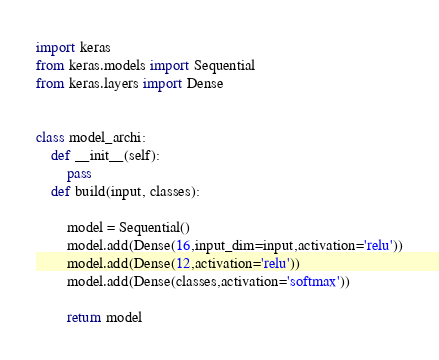Convert code to text. <code><loc_0><loc_0><loc_500><loc_500><_Python_>import keras
from keras.models import Sequential
from keras.layers import Dense


class model_archi:
    def __init__(self):
        pass
    def build(input, classes):

        model = Sequential()
        model.add(Dense(16,input_dim=input,activation='relu'))
        model.add(Dense(12,activation='relu'))
        model.add(Dense(classes,activation='softmax'))
        
        return model
</code> 